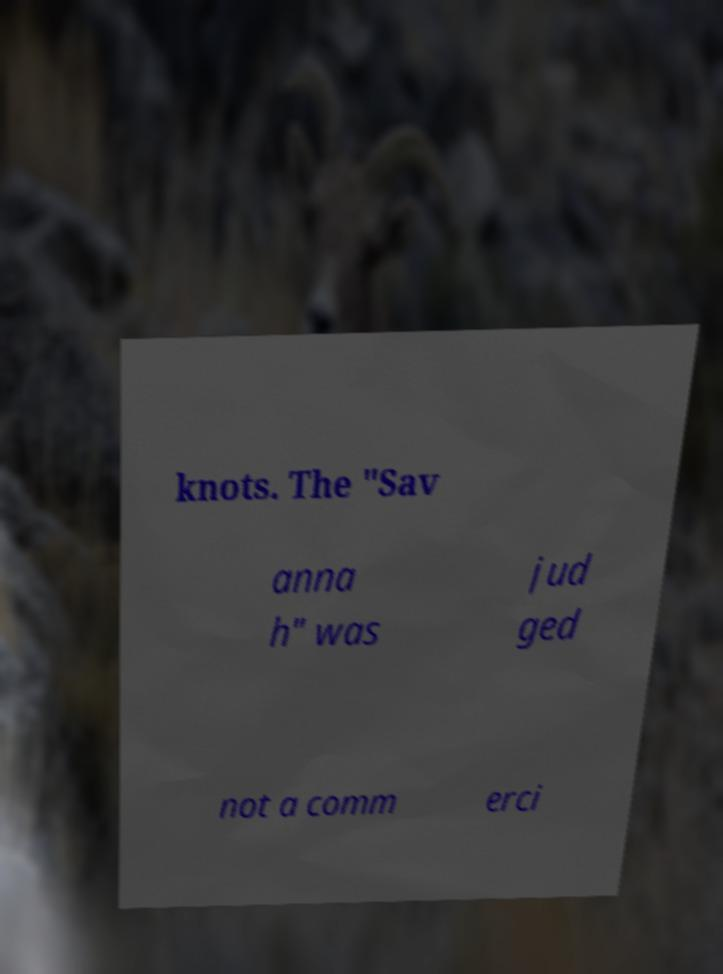I need the written content from this picture converted into text. Can you do that? knots. The "Sav anna h" was jud ged not a comm erci 